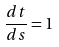<formula> <loc_0><loc_0><loc_500><loc_500>\frac { d t } { d s } = 1</formula> 